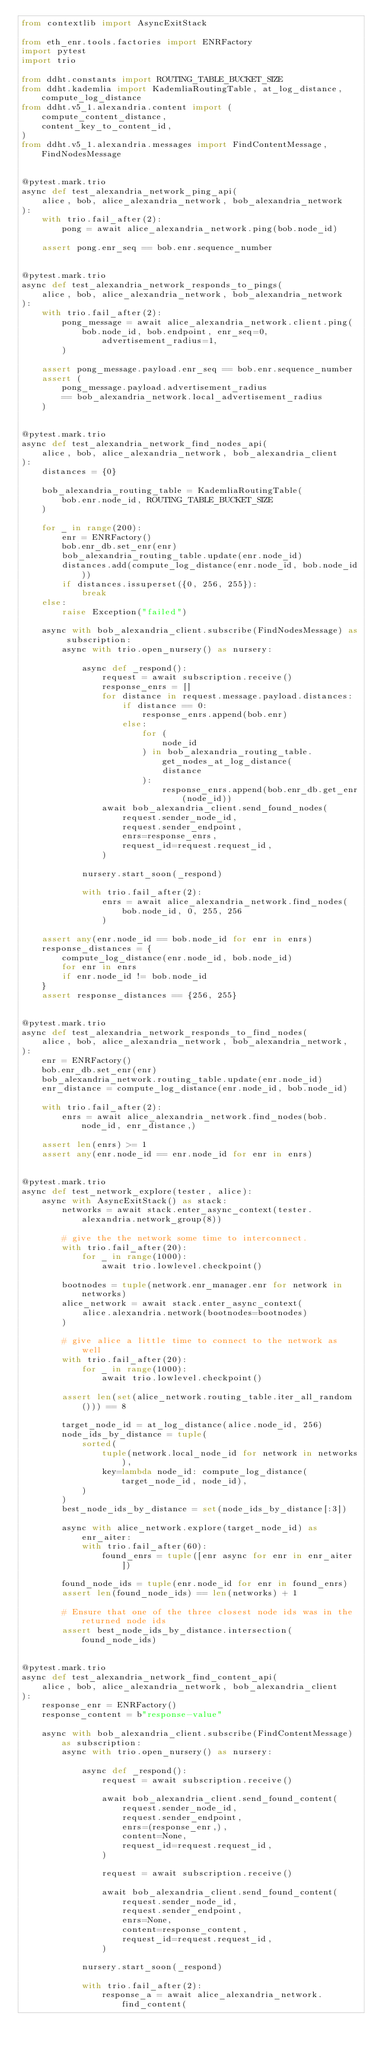<code> <loc_0><loc_0><loc_500><loc_500><_Python_>from contextlib import AsyncExitStack

from eth_enr.tools.factories import ENRFactory
import pytest
import trio

from ddht.constants import ROUTING_TABLE_BUCKET_SIZE
from ddht.kademlia import KademliaRoutingTable, at_log_distance, compute_log_distance
from ddht.v5_1.alexandria.content import (
    compute_content_distance,
    content_key_to_content_id,
)
from ddht.v5_1.alexandria.messages import FindContentMessage, FindNodesMessage


@pytest.mark.trio
async def test_alexandria_network_ping_api(
    alice, bob, alice_alexandria_network, bob_alexandria_network
):
    with trio.fail_after(2):
        pong = await alice_alexandria_network.ping(bob.node_id)

    assert pong.enr_seq == bob.enr.sequence_number


@pytest.mark.trio
async def test_alexandria_network_responds_to_pings(
    alice, bob, alice_alexandria_network, bob_alexandria_network
):
    with trio.fail_after(2):
        pong_message = await alice_alexandria_network.client.ping(
            bob.node_id, bob.endpoint, enr_seq=0, advertisement_radius=1,
        )

    assert pong_message.payload.enr_seq == bob.enr.sequence_number
    assert (
        pong_message.payload.advertisement_radius
        == bob_alexandria_network.local_advertisement_radius
    )


@pytest.mark.trio
async def test_alexandria_network_find_nodes_api(
    alice, bob, alice_alexandria_network, bob_alexandria_client
):
    distances = {0}

    bob_alexandria_routing_table = KademliaRoutingTable(
        bob.enr.node_id, ROUTING_TABLE_BUCKET_SIZE
    )

    for _ in range(200):
        enr = ENRFactory()
        bob.enr_db.set_enr(enr)
        bob_alexandria_routing_table.update(enr.node_id)
        distances.add(compute_log_distance(enr.node_id, bob.node_id))
        if distances.issuperset({0, 256, 255}):
            break
    else:
        raise Exception("failed")

    async with bob_alexandria_client.subscribe(FindNodesMessage) as subscription:
        async with trio.open_nursery() as nursery:

            async def _respond():
                request = await subscription.receive()
                response_enrs = []
                for distance in request.message.payload.distances:
                    if distance == 0:
                        response_enrs.append(bob.enr)
                    else:
                        for (
                            node_id
                        ) in bob_alexandria_routing_table.get_nodes_at_log_distance(
                            distance
                        ):
                            response_enrs.append(bob.enr_db.get_enr(node_id))
                await bob_alexandria_client.send_found_nodes(
                    request.sender_node_id,
                    request.sender_endpoint,
                    enrs=response_enrs,
                    request_id=request.request_id,
                )

            nursery.start_soon(_respond)

            with trio.fail_after(2):
                enrs = await alice_alexandria_network.find_nodes(
                    bob.node_id, 0, 255, 256
                )

    assert any(enr.node_id == bob.node_id for enr in enrs)
    response_distances = {
        compute_log_distance(enr.node_id, bob.node_id)
        for enr in enrs
        if enr.node_id != bob.node_id
    }
    assert response_distances == {256, 255}


@pytest.mark.trio
async def test_alexandria_network_responds_to_find_nodes(
    alice, bob, alice_alexandria_network, bob_alexandria_network,
):
    enr = ENRFactory()
    bob.enr_db.set_enr(enr)
    bob_alexandria_network.routing_table.update(enr.node_id)
    enr_distance = compute_log_distance(enr.node_id, bob.node_id)

    with trio.fail_after(2):
        enrs = await alice_alexandria_network.find_nodes(bob.node_id, enr_distance,)

    assert len(enrs) >= 1
    assert any(enr.node_id == enr.node_id for enr in enrs)


@pytest.mark.trio
async def test_network_explore(tester, alice):
    async with AsyncExitStack() as stack:
        networks = await stack.enter_async_context(tester.alexandria.network_group(8))

        # give the the network some time to interconnect.
        with trio.fail_after(20):
            for _ in range(1000):
                await trio.lowlevel.checkpoint()

        bootnodes = tuple(network.enr_manager.enr for network in networks)
        alice_network = await stack.enter_async_context(
            alice.alexandria.network(bootnodes=bootnodes)
        )

        # give alice a little time to connect to the network as well
        with trio.fail_after(20):
            for _ in range(1000):
                await trio.lowlevel.checkpoint()

        assert len(set(alice_network.routing_table.iter_all_random())) == 8

        target_node_id = at_log_distance(alice.node_id, 256)
        node_ids_by_distance = tuple(
            sorted(
                tuple(network.local_node_id for network in networks),
                key=lambda node_id: compute_log_distance(target_node_id, node_id),
            )
        )
        best_node_ids_by_distance = set(node_ids_by_distance[:3])

        async with alice_network.explore(target_node_id) as enr_aiter:
            with trio.fail_after(60):
                found_enrs = tuple([enr async for enr in enr_aiter])

        found_node_ids = tuple(enr.node_id for enr in found_enrs)
        assert len(found_node_ids) == len(networks) + 1

        # Ensure that one of the three closest node ids was in the returned node ids
        assert best_node_ids_by_distance.intersection(found_node_ids)


@pytest.mark.trio
async def test_alexandria_network_find_content_api(
    alice, bob, alice_alexandria_network, bob_alexandria_client
):
    response_enr = ENRFactory()
    response_content = b"response-value"

    async with bob_alexandria_client.subscribe(FindContentMessage) as subscription:
        async with trio.open_nursery() as nursery:

            async def _respond():
                request = await subscription.receive()

                await bob_alexandria_client.send_found_content(
                    request.sender_node_id,
                    request.sender_endpoint,
                    enrs=(response_enr,),
                    content=None,
                    request_id=request.request_id,
                )

                request = await subscription.receive()

                await bob_alexandria_client.send_found_content(
                    request.sender_node_id,
                    request.sender_endpoint,
                    enrs=None,
                    content=response_content,
                    request_id=request.request_id,
                )

            nursery.start_soon(_respond)

            with trio.fail_after(2):
                response_a = await alice_alexandria_network.find_content(</code> 